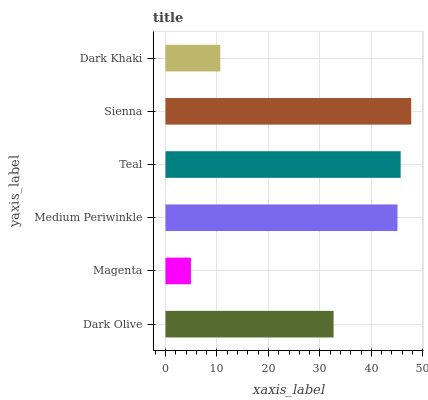Is Magenta the minimum?
Answer yes or no. Yes. Is Sienna the maximum?
Answer yes or no. Yes. Is Medium Periwinkle the minimum?
Answer yes or no. No. Is Medium Periwinkle the maximum?
Answer yes or no. No. Is Medium Periwinkle greater than Magenta?
Answer yes or no. Yes. Is Magenta less than Medium Periwinkle?
Answer yes or no. Yes. Is Magenta greater than Medium Periwinkle?
Answer yes or no. No. Is Medium Periwinkle less than Magenta?
Answer yes or no. No. Is Medium Periwinkle the high median?
Answer yes or no. Yes. Is Dark Olive the low median?
Answer yes or no. Yes. Is Dark Khaki the high median?
Answer yes or no. No. Is Teal the low median?
Answer yes or no. No. 